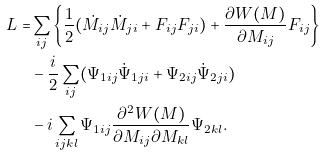Convert formula to latex. <formula><loc_0><loc_0><loc_500><loc_500>L = & \sum _ { i j } \left \{ \frac { 1 } { 2 } ( \dot { M } _ { i j } \dot { M } _ { j i } + F _ { i j } F _ { j i } ) + \frac { \partial W ( M ) } { \partial M _ { i j } } F _ { i j } \right \} \\ & - \frac { i } { 2 } \sum _ { i j } ( \Psi _ { 1 i j } \dot { \Psi } _ { 1 j i } + \Psi _ { 2 i j } \dot { \Psi } _ { 2 j i } ) \\ & - i \sum _ { i j k l } \Psi _ { 1 i j } \frac { \partial ^ { 2 } W ( M ) } { \partial M _ { i j } \partial M _ { k l } } \Psi _ { 2 k l } .</formula> 